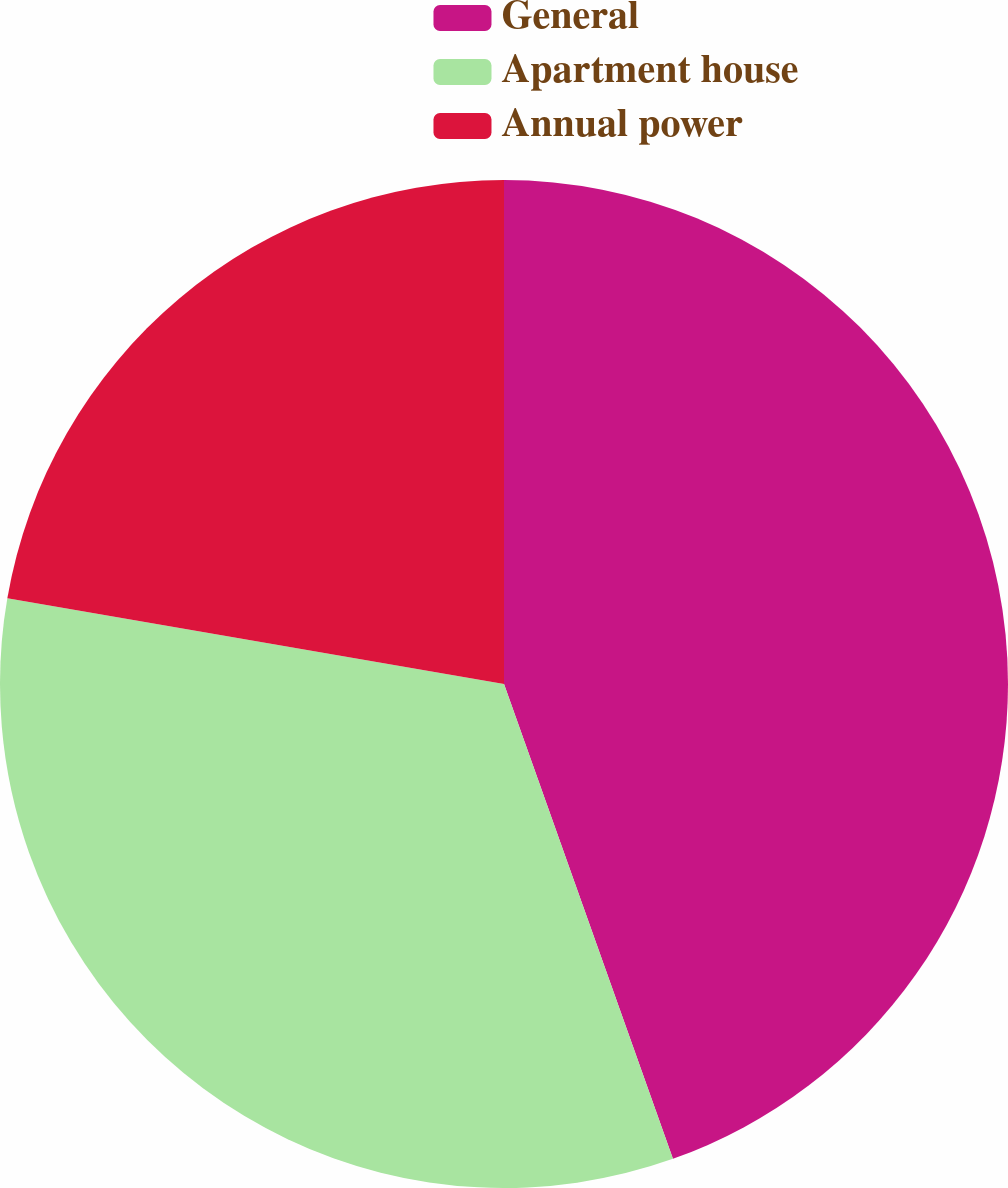Convert chart. <chart><loc_0><loc_0><loc_500><loc_500><pie_chart><fcel>General<fcel>Apartment house<fcel>Annual power<nl><fcel>44.56%<fcel>33.16%<fcel>22.28%<nl></chart> 